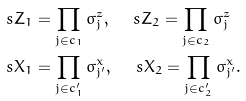Convert formula to latex. <formula><loc_0><loc_0><loc_500><loc_500>& \ s Z _ { 1 } = \prod _ { j \in c _ { 1 } } \sigma _ { j } ^ { z } , \quad \ s Z _ { 2 } = \prod _ { j \in c _ { 2 } } \sigma _ { j } ^ { z } \\ & \ s X _ { 1 } = \prod _ { j \in c _ { 1 } ^ { \prime } } \sigma _ { j ^ { \prime } } ^ { x } , \quad \ s X _ { 2 } = \prod _ { j \in c _ { 2 } ^ { \prime } } \sigma _ { j ^ { \prime } } ^ { x } .</formula> 